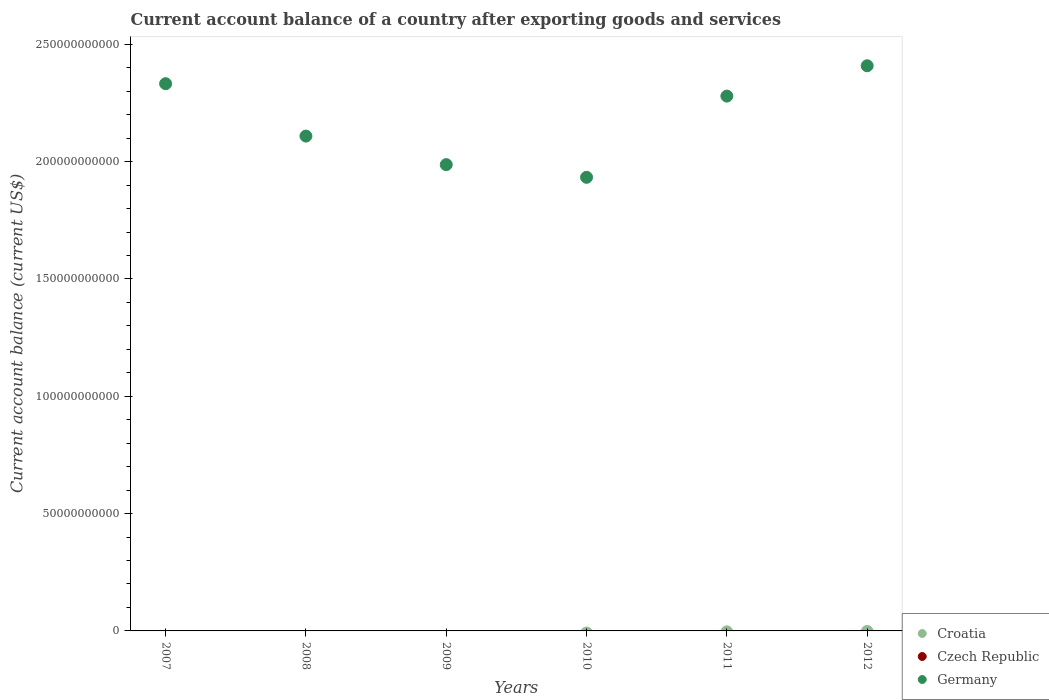How many different coloured dotlines are there?
Your answer should be very brief. 1. What is the account balance in Croatia in 2007?
Make the answer very short. 0. Across all years, what is the maximum account balance in Germany?
Your answer should be compact. 2.41e+11. Across all years, what is the minimum account balance in Germany?
Provide a succinct answer. 1.93e+11. What is the total account balance in Croatia in the graph?
Your answer should be very brief. 0. What is the difference between the account balance in Germany in 2008 and that in 2012?
Provide a short and direct response. -3.00e+1. What is the difference between the account balance in Germany in 2011 and the account balance in Croatia in 2008?
Provide a succinct answer. 2.28e+11. What is the average account balance in Czech Republic per year?
Make the answer very short. 0. In how many years, is the account balance in Croatia greater than 80000000000 US$?
Your response must be concise. 0. What is the ratio of the account balance in Germany in 2008 to that in 2009?
Give a very brief answer. 1.06. What is the difference between the highest and the second highest account balance in Germany?
Provide a succinct answer. 7.64e+09. What is the difference between the highest and the lowest account balance in Germany?
Offer a very short reply. 4.75e+1. Is the sum of the account balance in Germany in 2007 and 2010 greater than the maximum account balance in Croatia across all years?
Provide a succinct answer. Yes. Is it the case that in every year, the sum of the account balance in Croatia and account balance in Germany  is greater than the account balance in Czech Republic?
Give a very brief answer. Yes. Is the account balance in Germany strictly greater than the account balance in Croatia over the years?
Your response must be concise. Yes. How many years are there in the graph?
Give a very brief answer. 6. What is the difference between two consecutive major ticks on the Y-axis?
Give a very brief answer. 5.00e+1. Are the values on the major ticks of Y-axis written in scientific E-notation?
Provide a succinct answer. No. Where does the legend appear in the graph?
Provide a succinct answer. Bottom right. What is the title of the graph?
Your answer should be compact. Current account balance of a country after exporting goods and services. What is the label or title of the X-axis?
Offer a very short reply. Years. What is the label or title of the Y-axis?
Give a very brief answer. Current account balance (current US$). What is the Current account balance (current US$) of Croatia in 2007?
Provide a succinct answer. 0. What is the Current account balance (current US$) of Czech Republic in 2007?
Offer a very short reply. 0. What is the Current account balance (current US$) of Germany in 2007?
Offer a very short reply. 2.33e+11. What is the Current account balance (current US$) of Croatia in 2008?
Keep it short and to the point. 0. What is the Current account balance (current US$) in Czech Republic in 2008?
Provide a short and direct response. 0. What is the Current account balance (current US$) in Germany in 2008?
Offer a very short reply. 2.11e+11. What is the Current account balance (current US$) of Croatia in 2009?
Offer a terse response. 0. What is the Current account balance (current US$) in Czech Republic in 2009?
Your answer should be compact. 0. What is the Current account balance (current US$) in Germany in 2009?
Offer a very short reply. 1.99e+11. What is the Current account balance (current US$) in Germany in 2010?
Your answer should be very brief. 1.93e+11. What is the Current account balance (current US$) of Czech Republic in 2011?
Offer a terse response. 0. What is the Current account balance (current US$) of Germany in 2011?
Your answer should be very brief. 2.28e+11. What is the Current account balance (current US$) of Germany in 2012?
Provide a succinct answer. 2.41e+11. Across all years, what is the maximum Current account balance (current US$) in Germany?
Provide a short and direct response. 2.41e+11. Across all years, what is the minimum Current account balance (current US$) in Germany?
Ensure brevity in your answer.  1.93e+11. What is the total Current account balance (current US$) in Croatia in the graph?
Make the answer very short. 0. What is the total Current account balance (current US$) in Czech Republic in the graph?
Make the answer very short. 0. What is the total Current account balance (current US$) of Germany in the graph?
Make the answer very short. 1.30e+12. What is the difference between the Current account balance (current US$) of Germany in 2007 and that in 2008?
Provide a short and direct response. 2.23e+1. What is the difference between the Current account balance (current US$) of Germany in 2007 and that in 2009?
Offer a very short reply. 3.45e+1. What is the difference between the Current account balance (current US$) of Germany in 2007 and that in 2010?
Make the answer very short. 3.99e+1. What is the difference between the Current account balance (current US$) of Germany in 2007 and that in 2011?
Offer a very short reply. 5.28e+09. What is the difference between the Current account balance (current US$) in Germany in 2007 and that in 2012?
Make the answer very short. -7.64e+09. What is the difference between the Current account balance (current US$) in Germany in 2008 and that in 2009?
Your answer should be very brief. 1.22e+1. What is the difference between the Current account balance (current US$) in Germany in 2008 and that in 2010?
Ensure brevity in your answer.  1.76e+1. What is the difference between the Current account balance (current US$) of Germany in 2008 and that in 2011?
Keep it short and to the point. -1.70e+1. What is the difference between the Current account balance (current US$) of Germany in 2008 and that in 2012?
Your answer should be very brief. -3.00e+1. What is the difference between the Current account balance (current US$) in Germany in 2009 and that in 2010?
Keep it short and to the point. 5.40e+09. What is the difference between the Current account balance (current US$) of Germany in 2009 and that in 2011?
Provide a succinct answer. -2.92e+1. What is the difference between the Current account balance (current US$) of Germany in 2009 and that in 2012?
Your answer should be very brief. -4.21e+1. What is the difference between the Current account balance (current US$) of Germany in 2010 and that in 2011?
Provide a short and direct response. -3.46e+1. What is the difference between the Current account balance (current US$) of Germany in 2010 and that in 2012?
Provide a short and direct response. -4.75e+1. What is the difference between the Current account balance (current US$) in Germany in 2011 and that in 2012?
Your response must be concise. -1.29e+1. What is the average Current account balance (current US$) of Germany per year?
Offer a very short reply. 2.17e+11. What is the ratio of the Current account balance (current US$) of Germany in 2007 to that in 2008?
Provide a succinct answer. 1.11. What is the ratio of the Current account balance (current US$) of Germany in 2007 to that in 2009?
Offer a very short reply. 1.17. What is the ratio of the Current account balance (current US$) of Germany in 2007 to that in 2010?
Offer a very short reply. 1.21. What is the ratio of the Current account balance (current US$) of Germany in 2007 to that in 2011?
Make the answer very short. 1.02. What is the ratio of the Current account balance (current US$) of Germany in 2007 to that in 2012?
Your answer should be very brief. 0.97. What is the ratio of the Current account balance (current US$) in Germany in 2008 to that in 2009?
Provide a short and direct response. 1.06. What is the ratio of the Current account balance (current US$) in Germany in 2008 to that in 2011?
Your response must be concise. 0.93. What is the ratio of the Current account balance (current US$) of Germany in 2008 to that in 2012?
Provide a succinct answer. 0.88. What is the ratio of the Current account balance (current US$) of Germany in 2009 to that in 2010?
Give a very brief answer. 1.03. What is the ratio of the Current account balance (current US$) of Germany in 2009 to that in 2011?
Ensure brevity in your answer.  0.87. What is the ratio of the Current account balance (current US$) in Germany in 2009 to that in 2012?
Your answer should be very brief. 0.82. What is the ratio of the Current account balance (current US$) in Germany in 2010 to that in 2011?
Offer a terse response. 0.85. What is the ratio of the Current account balance (current US$) in Germany in 2010 to that in 2012?
Make the answer very short. 0.8. What is the ratio of the Current account balance (current US$) in Germany in 2011 to that in 2012?
Provide a succinct answer. 0.95. What is the difference between the highest and the second highest Current account balance (current US$) in Germany?
Your response must be concise. 7.64e+09. What is the difference between the highest and the lowest Current account balance (current US$) in Germany?
Provide a succinct answer. 4.75e+1. 